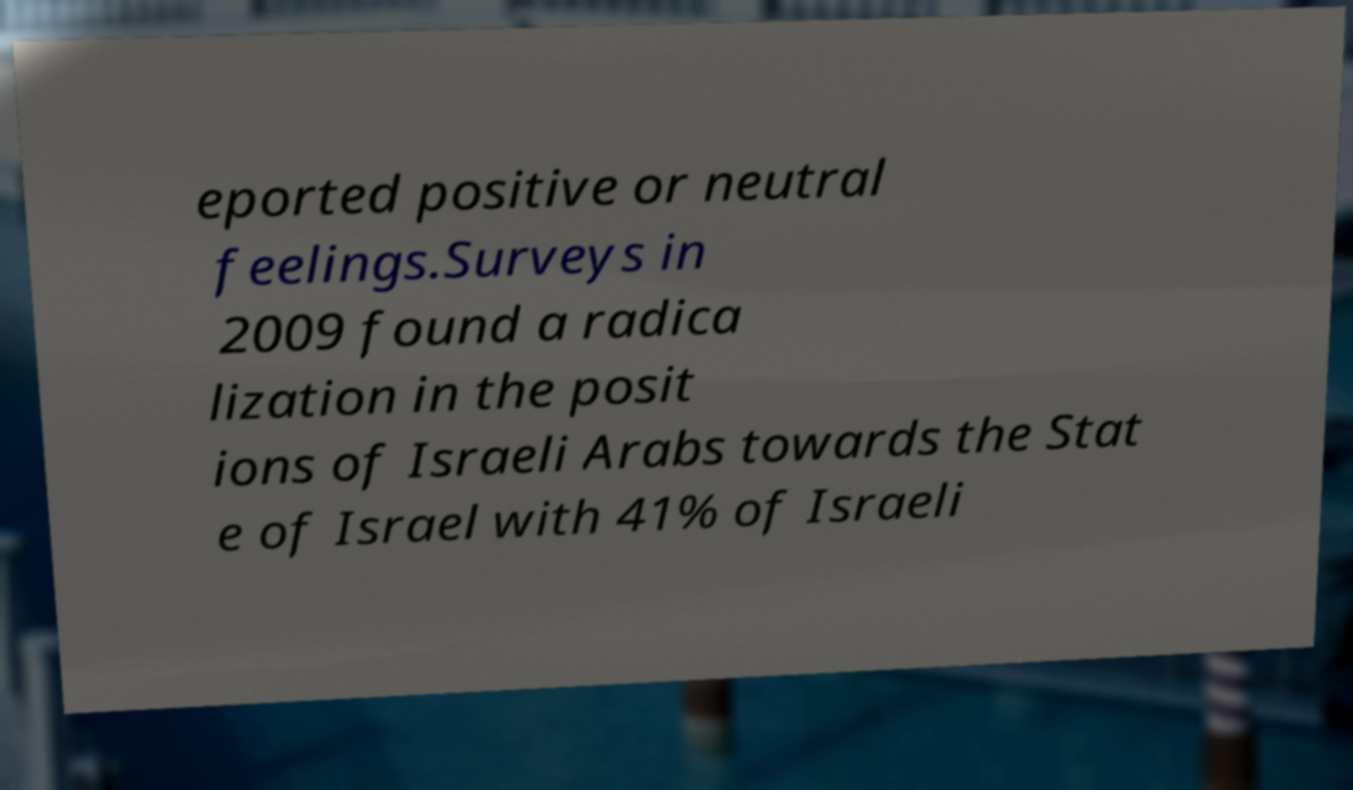What messages or text are displayed in this image? I need them in a readable, typed format. eported positive or neutral feelings.Surveys in 2009 found a radica lization in the posit ions of Israeli Arabs towards the Stat e of Israel with 41% of Israeli 